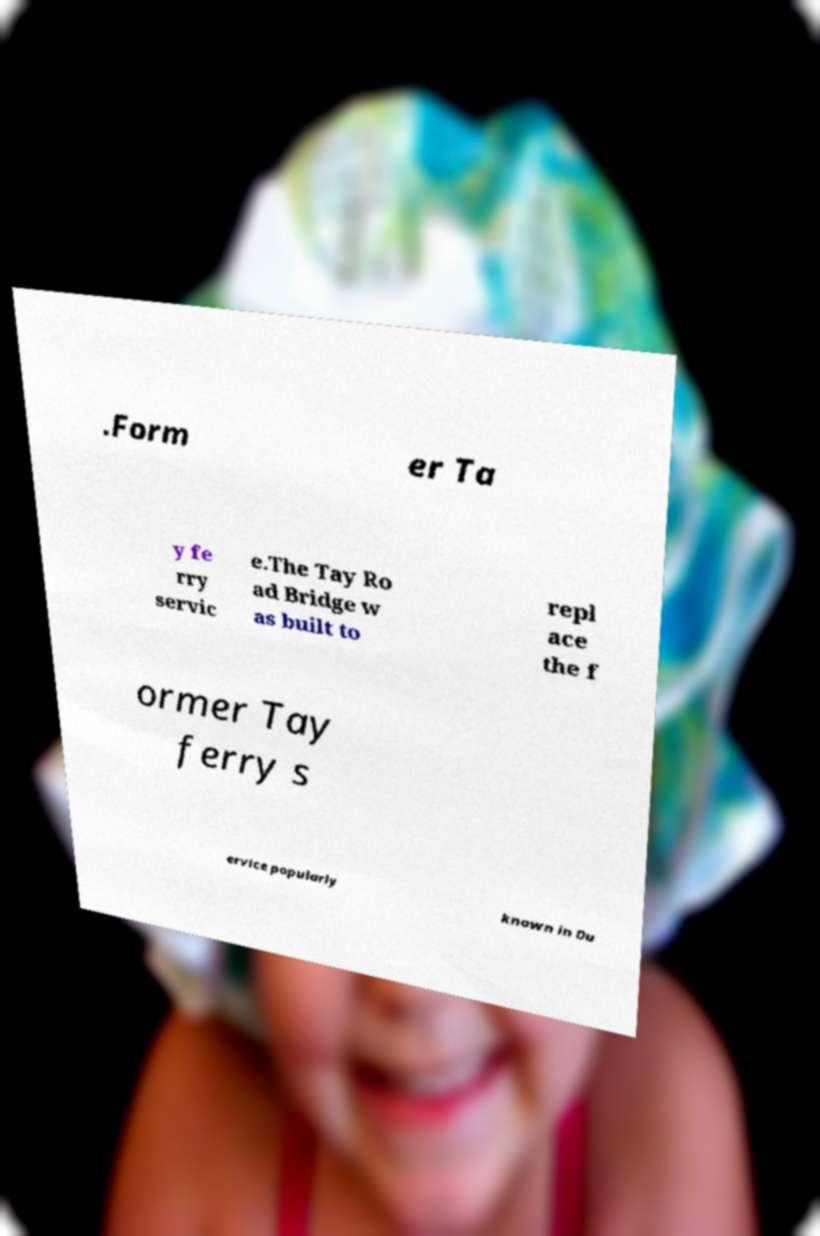For documentation purposes, I need the text within this image transcribed. Could you provide that? .Form er Ta y fe rry servic e.The Tay Ro ad Bridge w as built to repl ace the f ormer Tay ferry s ervice popularly known in Du 